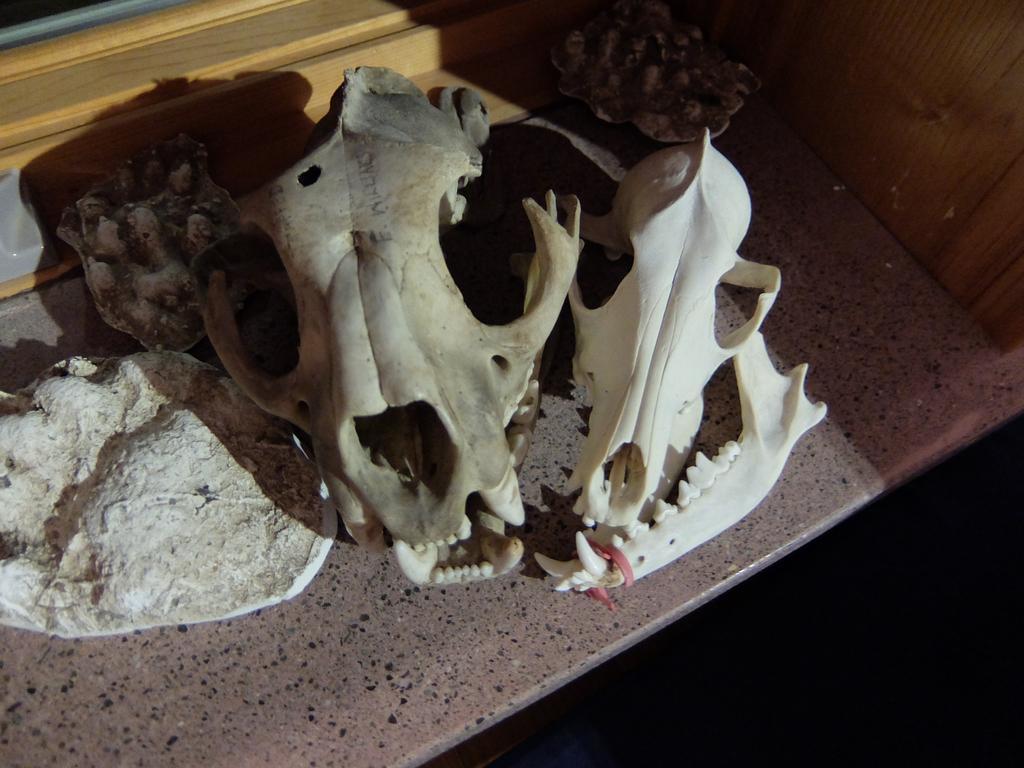Can you describe this image briefly? In this picture I can see skulls and bones of animals, on an object. 